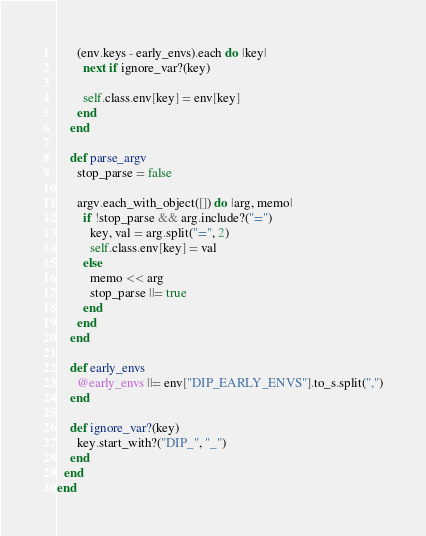<code> <loc_0><loc_0><loc_500><loc_500><_Ruby_>      (env.keys - early_envs).each do |key|
        next if ignore_var?(key)

        self.class.env[key] = env[key]
      end
    end

    def parse_argv
      stop_parse = false

      argv.each_with_object([]) do |arg, memo|
        if !stop_parse && arg.include?("=")
          key, val = arg.split("=", 2)
          self.class.env[key] = val
        else
          memo << arg
          stop_parse ||= true
        end
      end
    end

    def early_envs
      @early_envs ||= env["DIP_EARLY_ENVS"].to_s.split(",")
    end

    def ignore_var?(key)
      key.start_with?("DIP_", "_")
    end
  end
end
</code> 